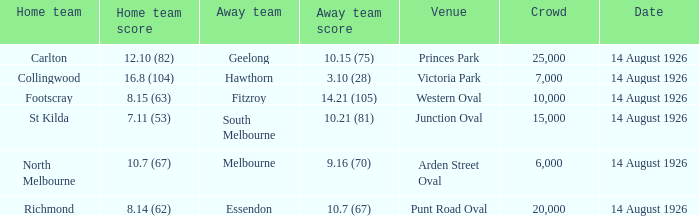In which match with the smallest crowd did an away team manage to score 3.10 (28)? 7000.0. 